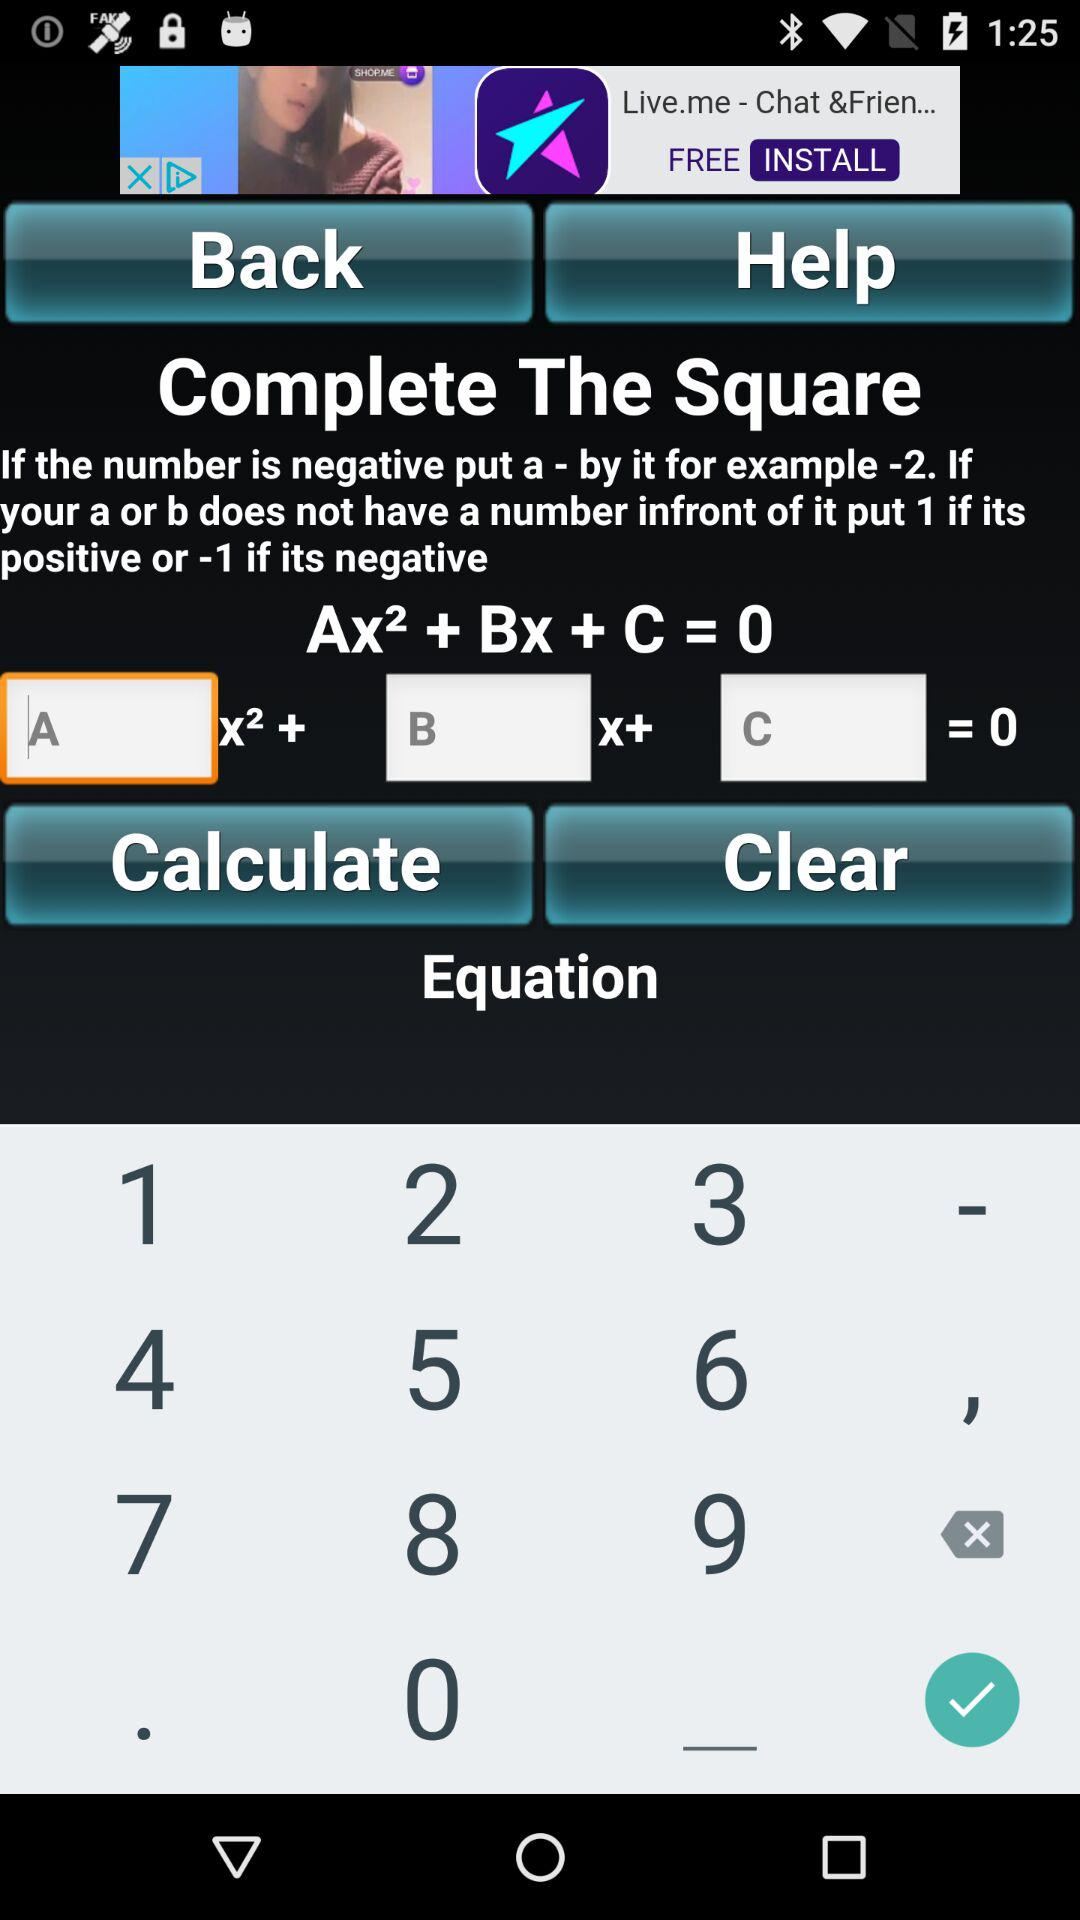How many text inputs are there for the coefficients of the equation?
Answer the question using a single word or phrase. 3 